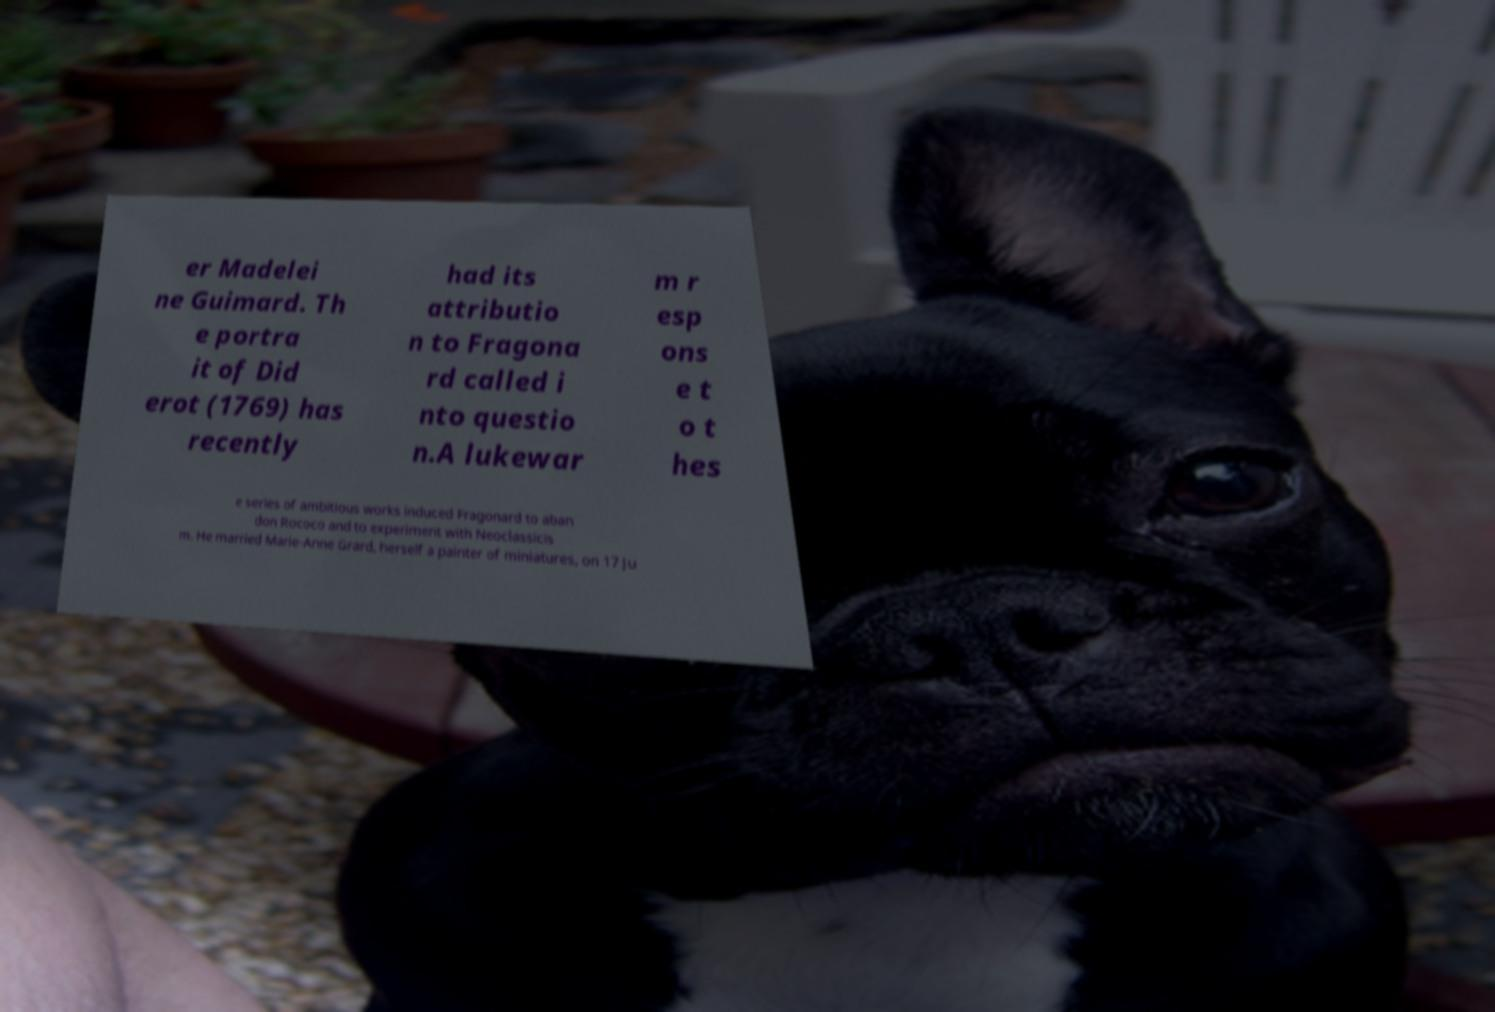Could you extract and type out the text from this image? er Madelei ne Guimard. Th e portra it of Did erot (1769) has recently had its attributio n to Fragona rd called i nto questio n.A lukewar m r esp ons e t o t hes e series of ambitious works induced Fragonard to aban don Rococo and to experiment with Neoclassicis m. He married Marie-Anne Grard, herself a painter of miniatures, on 17 Ju 